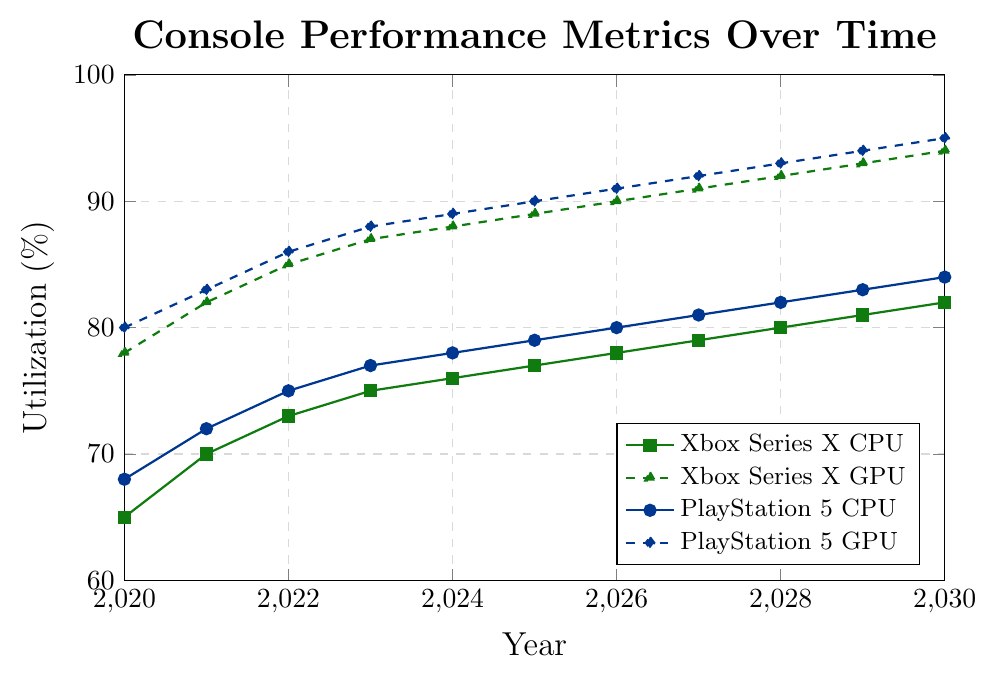What is the trend of CPU utilization for Xbox Series X from 2020 to 2030? The CPU utilization for Xbox Series X shows a consistent upward trend from 65% in 2020 to 82% in 2030.
Answer: Upward trend Which year did Xbox Series X GPU utilization surpass 90%? By observing the line representing Xbox Series X GPU utilization, we see it surpasses 90% in 2026.
Answer: 2026 How much did the PlayStation 5 GPU utilization change from 2020 to 2030? The PlayStation 5 GPU utilization increased from 80% in 2020 to 95% in 2030. The change is 95% - 80% = 15%.
Answer: 15% Which console had higher CPU utilization in 2024, Xbox Series X or PlayStation 5? By comparing the data points for 2024, PlayStation 5 CPU utilization was 78%, while Xbox Series X CPU utilization was 76%.
Answer: PlayStation 5 What is the average GPU utilization for PlayStation 5 over the years 2020 to 2030? To find the average GPU utilization for PlayStation 5, sum the percentages for each year from 2020 to 2030 and divide by the number of years: (80 + 83 + 86 + 88 + 89 + 90 + 91 + 92 + 93 + 94 + 95)/11 = 881/11 = 80.09%.
Answer: 80.08% Which year has the minimum CPU utilization across both consoles? By observing the data, the minimum CPU utilization across both consoles occurs in 2020 for Xbox Series X with 65%.
Answer: 2020 In which year is the GPU utilization of Xbox Series X exactly equal to the CPU utilization of PlayStation 5? Comparing the points each year shows that in 2027, Xbox Series X GPU utilization (91%) is equal to PlayStation 5 CPU utilization (81%).
Answer: 2027 What is the difference in GPU utilization between Xbox Series X and PlayStation 5 in 2029? In 2029, Xbox Series X GPU utilization is 93%, and PlayStation 5 GPU utilization is 94%. The difference is 94% - 93% = 1%.
Answer: 1% How many years does the PlayStation 5 CPU utilization exceed 80%? By checking the PlayStation 5 CPU utilization data, it exceeds 80% between 2026 and 2030, lasting for 5 years.
Answer: 5 years If we consider both consoles together, which year shows the highest average GPU utilization? To find the year with the highest average GPU utilization, calculate the average each year and determine the maximum: (2030: Xbox Series X 94% + PlayStation 5 95%) / 2 = 94.5%.
Answer: 2030 